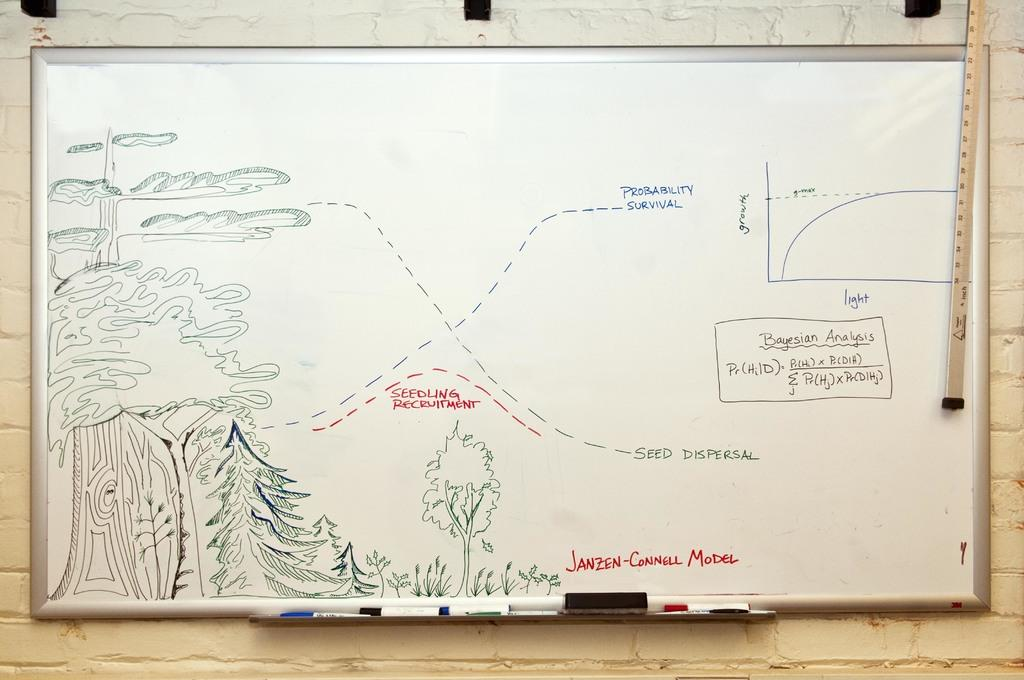<image>
Describe the image concisely. A whiteboard that illustrates the Janzen-Connell model on it. 